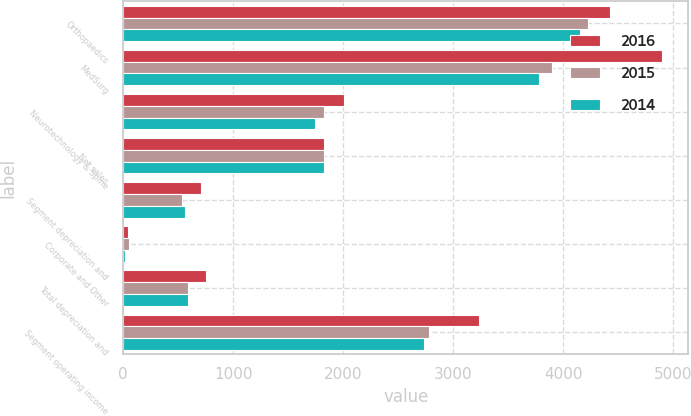<chart> <loc_0><loc_0><loc_500><loc_500><stacked_bar_chart><ecel><fcel>Orthopaedics<fcel>MedSurg<fcel>Neurotechnology & Spine<fcel>Net sales<fcel>Segment depreciation and<fcel>Corporate and Other<fcel>Total depreciation and<fcel>Segment operating income<nl><fcel>2016<fcel>4422<fcel>4894<fcel>2009<fcel>1828<fcel>706<fcel>46<fcel>752<fcel>3239<nl><fcel>2015<fcel>4223<fcel>3895<fcel>1828<fcel>1828<fcel>539<fcel>51<fcel>590<fcel>2783<nl><fcel>2014<fcel>4153<fcel>3781<fcel>1741<fcel>1828<fcel>566<fcel>20<fcel>586<fcel>2736<nl></chart> 